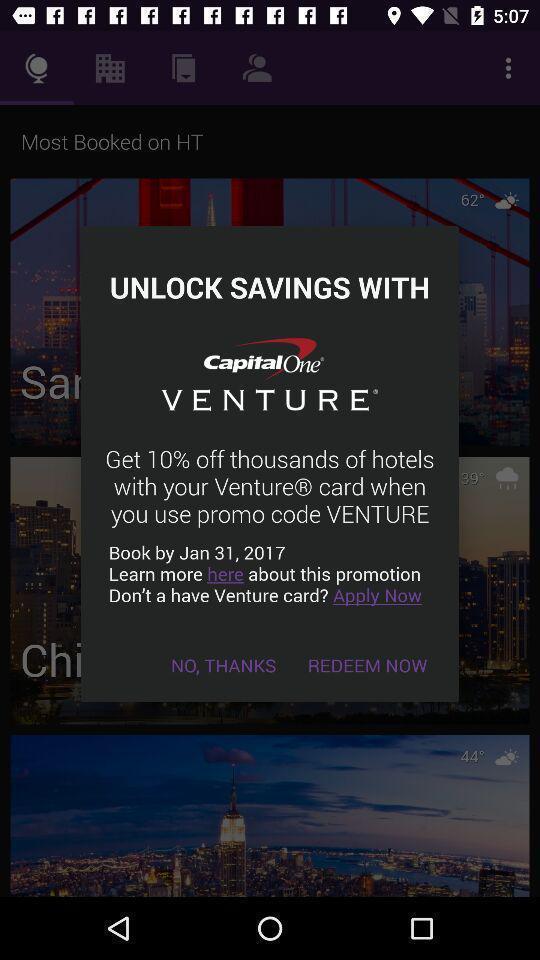Provide a textual representation of this image. Popup showing the offer for savings. 